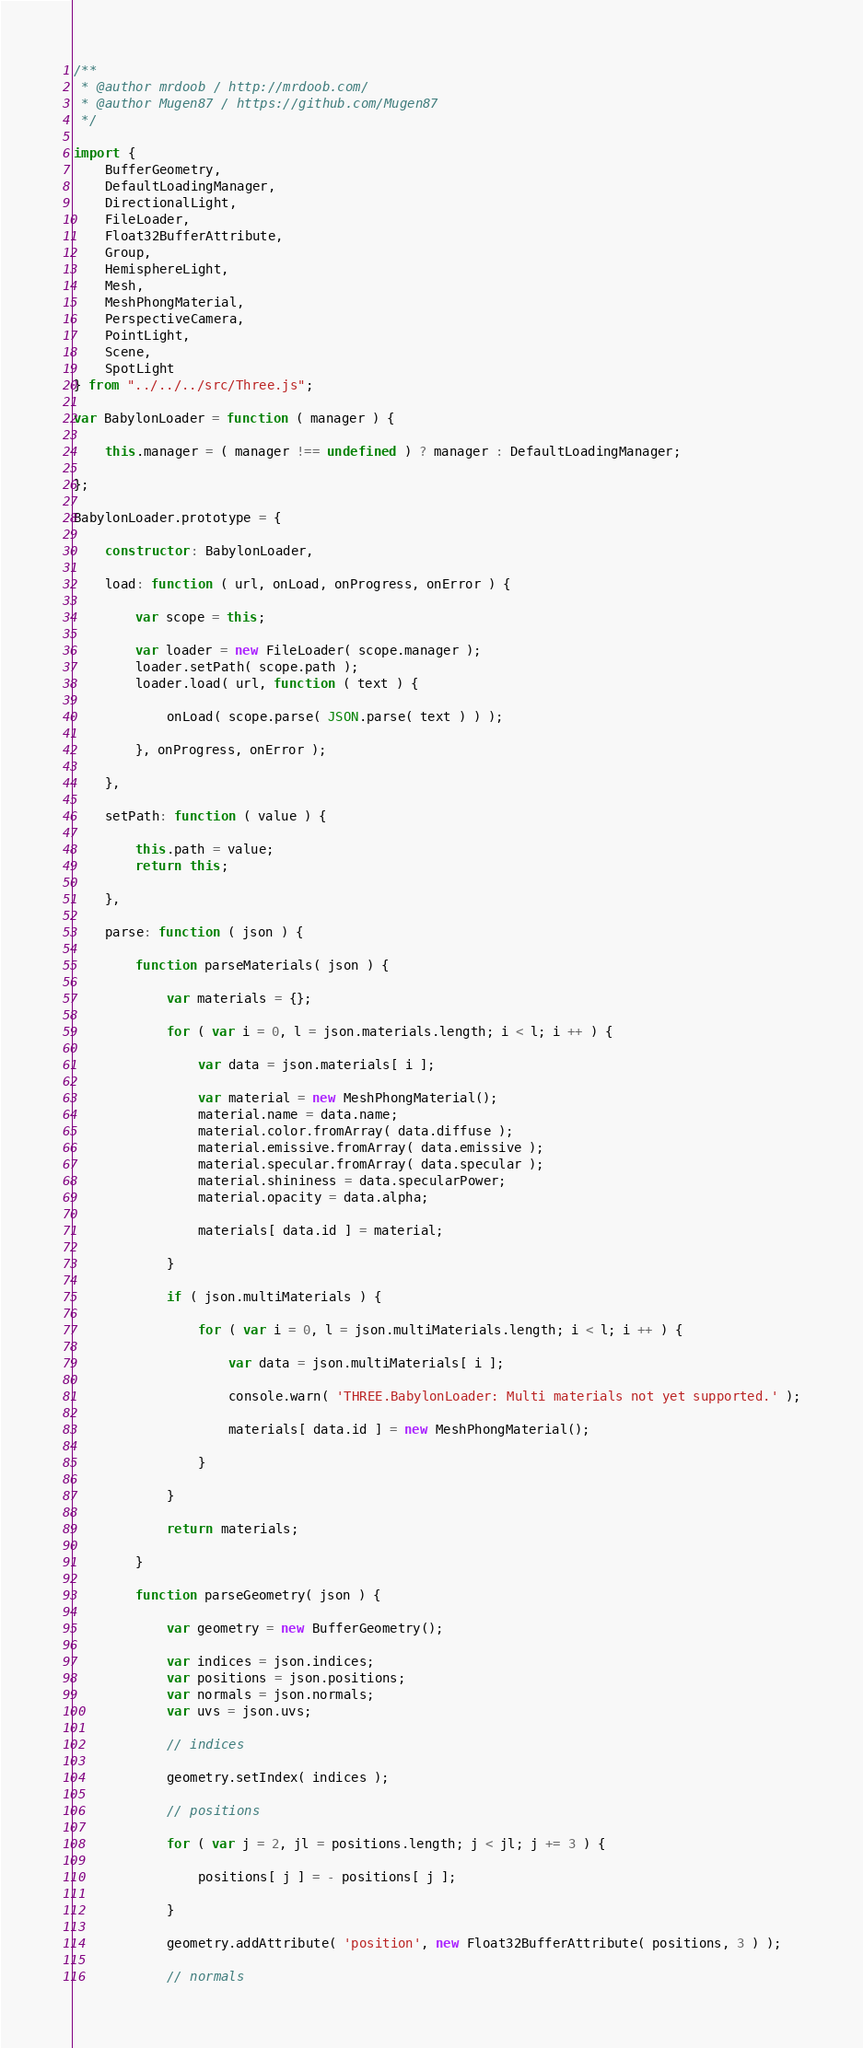<code> <loc_0><loc_0><loc_500><loc_500><_JavaScript_>/**
 * @author mrdoob / http://mrdoob.com/
 * @author Mugen87 / https://github.com/Mugen87
 */

import {
	BufferGeometry,
	DefaultLoadingManager,
	DirectionalLight,
	FileLoader,
	Float32BufferAttribute,
	Group,
	HemisphereLight,
	Mesh,
	MeshPhongMaterial,
	PerspectiveCamera,
	PointLight,
	Scene,
	SpotLight
} from "../../../src/Three.js";

var BabylonLoader = function ( manager ) {

	this.manager = ( manager !== undefined ) ? manager : DefaultLoadingManager;

};

BabylonLoader.prototype = {

	constructor: BabylonLoader,

	load: function ( url, onLoad, onProgress, onError ) {

		var scope = this;

		var loader = new FileLoader( scope.manager );
		loader.setPath( scope.path );
		loader.load( url, function ( text ) {

			onLoad( scope.parse( JSON.parse( text ) ) );

		}, onProgress, onError );

	},

	setPath: function ( value ) {

		this.path = value;
		return this;

	},

	parse: function ( json ) {

		function parseMaterials( json ) {

			var materials = {};

			for ( var i = 0, l = json.materials.length; i < l; i ++ ) {

				var data = json.materials[ i ];

				var material = new MeshPhongMaterial();
				material.name = data.name;
				material.color.fromArray( data.diffuse );
				material.emissive.fromArray( data.emissive );
				material.specular.fromArray( data.specular );
				material.shininess = data.specularPower;
				material.opacity = data.alpha;

				materials[ data.id ] = material;

			}

			if ( json.multiMaterials ) {

				for ( var i = 0, l = json.multiMaterials.length; i < l; i ++ ) {

					var data = json.multiMaterials[ i ];

					console.warn( 'THREE.BabylonLoader: Multi materials not yet supported.' );

					materials[ data.id ] = new MeshPhongMaterial();

				}

			}

			return materials;

		}

		function parseGeometry( json ) {

			var geometry = new BufferGeometry();

			var indices = json.indices;
			var positions = json.positions;
			var normals = json.normals;
			var uvs = json.uvs;

			// indices

			geometry.setIndex( indices );

			// positions

			for ( var j = 2, jl = positions.length; j < jl; j += 3 ) {

				positions[ j ] = - positions[ j ];

			}

			geometry.addAttribute( 'position', new Float32BufferAttribute( positions, 3 ) );

			// normals
</code> 